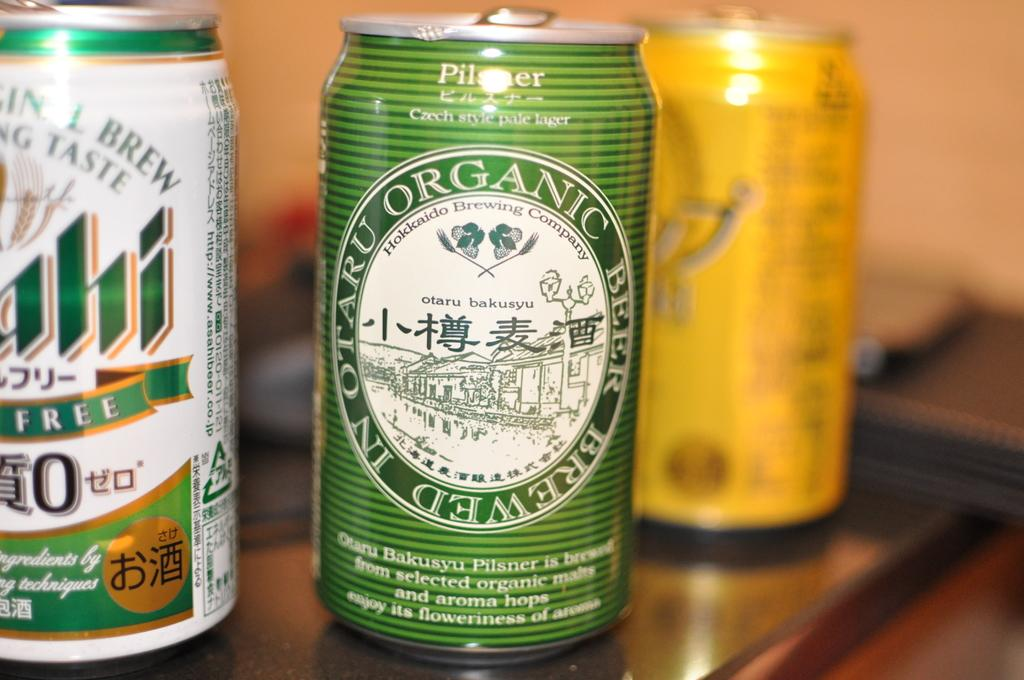Provide a one-sentence caption for the provided image. A can of In Otaru Organic Beer with a pictue of a town as its logo. 